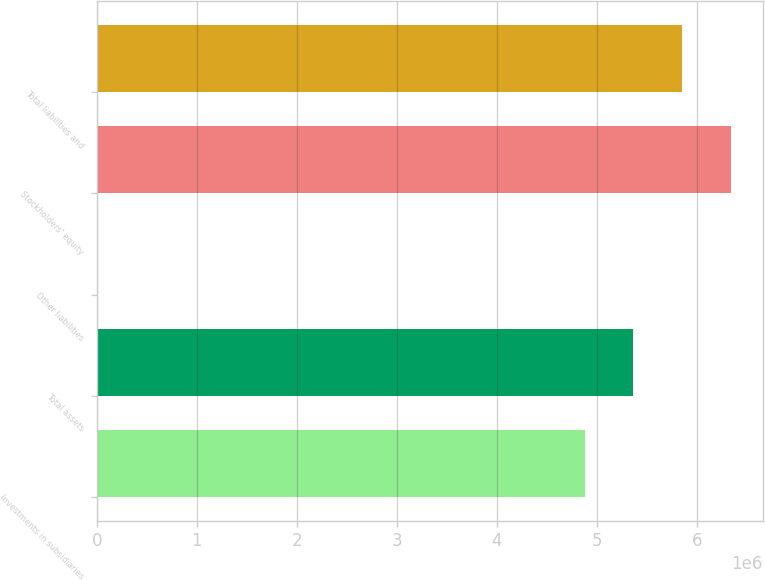Convert chart to OTSL. <chart><loc_0><loc_0><loc_500><loc_500><bar_chart><fcel>Investments in subsidiaries<fcel>Total assets<fcel>Other liabilities<fcel>Stockholders' equity<fcel>Total liabilities and<nl><fcel>4.87878e+06<fcel>5.36692e+06<fcel>8<fcel>6.34319e+06<fcel>5.85505e+06<nl></chart> 